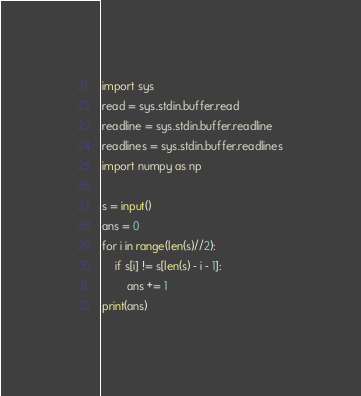Convert code to text. <code><loc_0><loc_0><loc_500><loc_500><_Python_>import sys
read = sys.stdin.buffer.read
readline = sys.stdin.buffer.readline
readlines = sys.stdin.buffer.readlines
import numpy as np

s = input()
ans = 0
for i in range(len(s)//2):
    if s[i] != s[len(s) - i - 1]:
        ans += 1
print(ans)</code> 